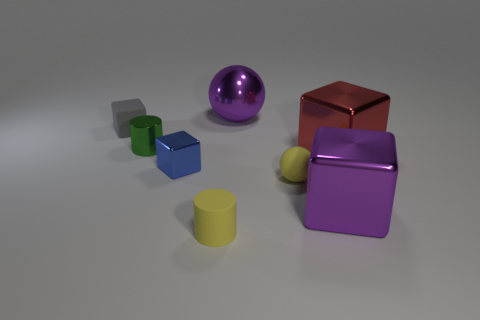There is a metallic cube that is on the left side of the rubber cylinder; does it have the same size as the big red thing?
Provide a short and direct response. No. There is a tiny thing that is to the right of the metallic sphere; what is it made of?
Keep it short and to the point. Rubber. What number of matte objects are either small gray objects or yellow balls?
Make the answer very short. 2. Are there fewer yellow objects on the left side of the tiny blue thing than tiny green cylinders?
Your answer should be compact. Yes. There is a big purple shiny thing in front of the tiny thing right of the big purple metal ball to the right of the tiny green cylinder; what shape is it?
Offer a terse response. Cube. Does the tiny rubber ball have the same color as the matte cylinder?
Your answer should be very brief. Yes. Is the number of spheres greater than the number of large purple metal spheres?
Give a very brief answer. Yes. What number of other things are the same material as the large red block?
Your response must be concise. 4. How many objects are large blue metallic balls or large purple objects behind the small gray rubber object?
Offer a very short reply. 1. Are there fewer large red cubes than purple metallic objects?
Provide a succinct answer. Yes. 